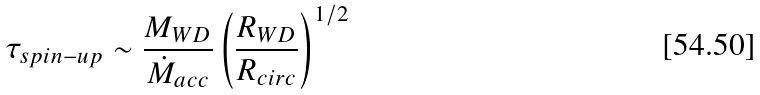Convert formula to latex. <formula><loc_0><loc_0><loc_500><loc_500>\tau _ { s p i n - u p } \sim \frac { M _ { W D } } { \dot { M } _ { a c c } } \left ( \frac { R _ { W D } } { R _ { c i r c } } \right ) ^ { 1 / 2 }</formula> 